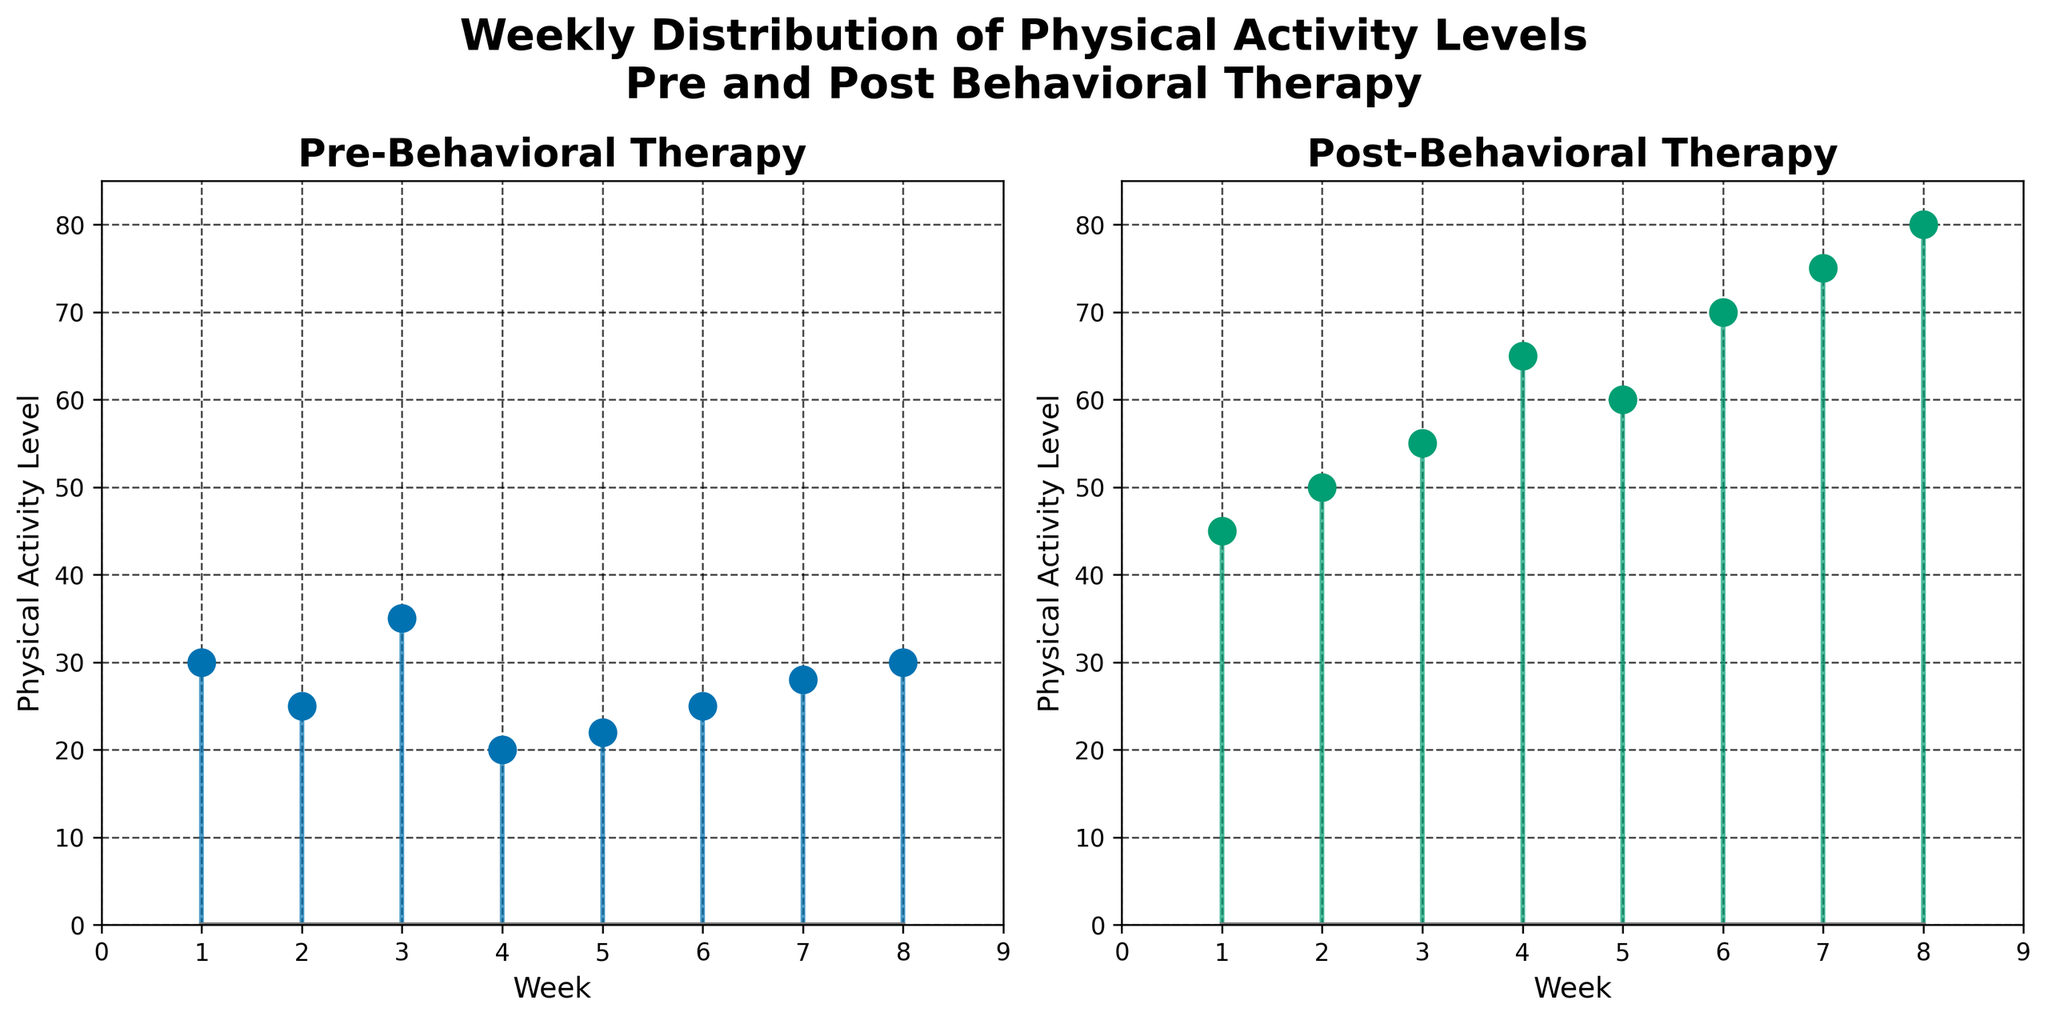What is the title of the figure? The title of the figure is displayed prominently at the top. It reads 'Weekly Distribution of Physical Activity Levels Pre and Post Behavioral Therapy'.
Answer: Weekly Distribution of Physical Activity Levels Pre and Post Behavioral Therapy How many weeks are displayed in the figure? The x-axis labels show the weeks from 1 to 8, indicating the number of weeks being represented.
Answer: 8 What is the physical activity level in Week 4 post behavioral therapy? The stem plot for Post-Behavioral Therapy shows an activity level of 65 in Week 4.
Answer: 65 Which week has the highest physical activity level post behavioral therapy? By looking at the highest point in the Post-Behavioral Therapy stem plot, Week 8 shows the highest level with a value of 80.
Answer: Week 8 What is the difference in physical activity level between Pre and Post Behavioral Therapy in Week 6? The activity level pre-therapy in Week 6 is 25, and post-therapy it is 70. The difference can be calculated as 70 - 25.
Answer: 45 Which week shows the lowest physical activity level pre behavioral therapy? The lowest point in the Pre-Behavioral Therapy stem plot is Week 4 with an activity level of 20.
Answer: Week 4 What is the overall trend observed in physical activity levels post behavioral therapy over the weeks? The Post-Behavioral Therapy stem plot shows a clear increasing trend in physical activity levels from Week 1 to Week 8.
Answer: Increasing How does the activity level change from Week 1 to Week 8 post behavioral therapy? At Week 1, the activity level is 45, and at Week 8, it reaches 80. The change is calculated as 80 - 45.
Answer: 35 What is the average physical activity level pre behavioral therapy? Sum up the pre-therapy values: 30 + 25 + 35 + 20 + 22 + 25 + 28 + 30 = 215. Then, divide by the number of weeks: 215/8.
Answer: 26.88 Is there any week where the physical activity level remained the same pre and post therapy? By comparing the activity levels for each week, none of the weeks have the same pre and post therapy levels.
Answer: No 